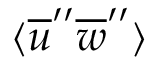<formula> <loc_0><loc_0><loc_500><loc_500>\langle \overline { u } ^ { \prime \prime } \overline { w } ^ { \prime \prime } \rangle</formula> 